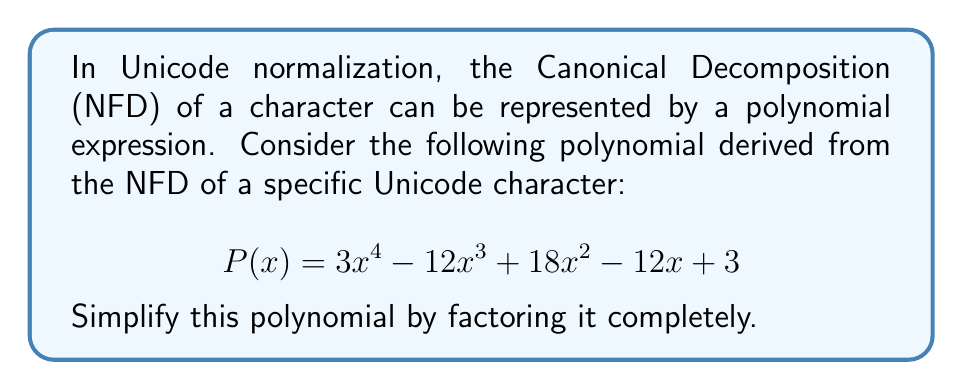Provide a solution to this math problem. To simplify this polynomial, we'll follow these steps:

1) First, let's check if there's a common factor for all terms:
   $$ 3x^4 - 12x^3 + 18x^2 - 12x + 3 $$
   There's no common factor for all terms.

2) Next, let's check if this is a perfect square trinomial or the difference of squares. It's neither, so we'll proceed with factoring by grouping.

3) Rewrite the polynomial, grouping terms:
   $$ (3x^4 - 12x^3) + (18x^2 - 12x + 3) $$

4) Factor out the common factor from the first group:
   $$ 3x^3(x - 4) + (18x^2 - 12x + 3) $$

5) The second group doesn't factor further, so let's look for a factor that could make this into a difference of squares.

6) Notice that the polynomial is symmetric (the coefficients are the same forward and backward). This suggests it might factor as $(ax^2 + bx + 1)(ax^2 + bx + 1)$.

7) Using the coefficients, we can deduce that $a = \sqrt{3}$ and $b = -2$.

8) Therefore, we can factor the polynomial as:
   $$ P(x) = (\sqrt{3}x^2 - 2x + 1)(\sqrt{3}x^2 - 2x + 1) $$

9) This can be written as:
   $$ P(x) = (\sqrt{3}x^2 - 2x + 1)^2 $$

This is the completely factored form of the polynomial.
Answer: $$ P(x) = (\sqrt{3}x^2 - 2x + 1)^2 $$ 